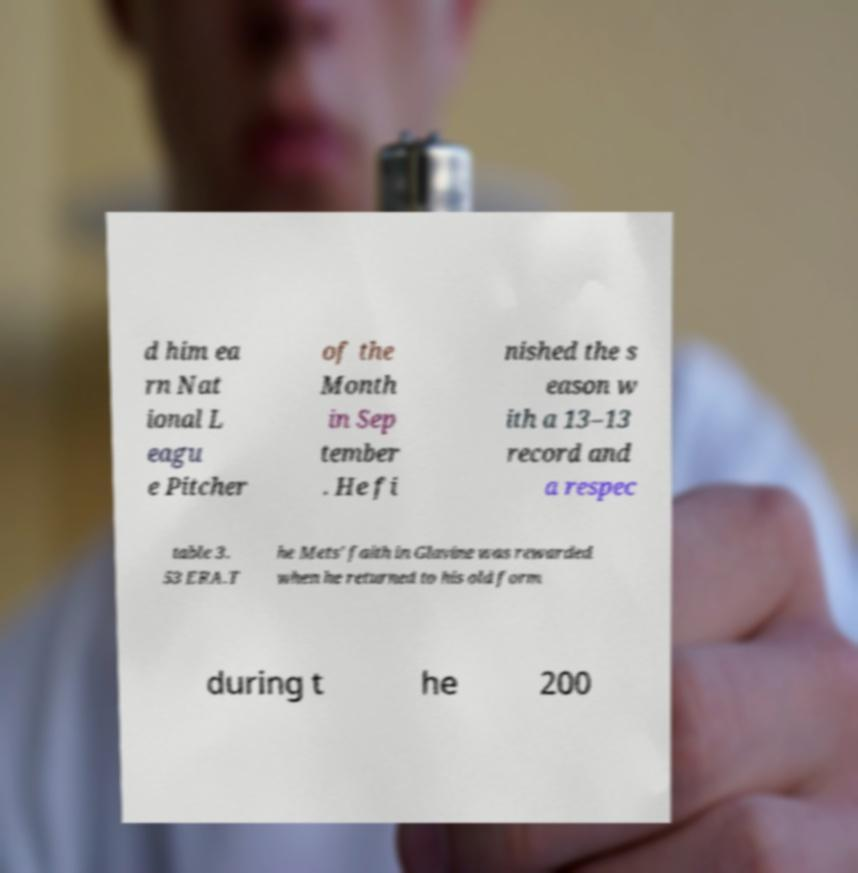What messages or text are displayed in this image? I need them in a readable, typed format. d him ea rn Nat ional L eagu e Pitcher of the Month in Sep tember . He fi nished the s eason w ith a 13–13 record and a respec table 3. 53 ERA.T he Mets' faith in Glavine was rewarded when he returned to his old form during t he 200 